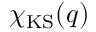Convert formula to latex. <formula><loc_0><loc_0><loc_500><loc_500>\chi _ { K S } ( q )</formula> 